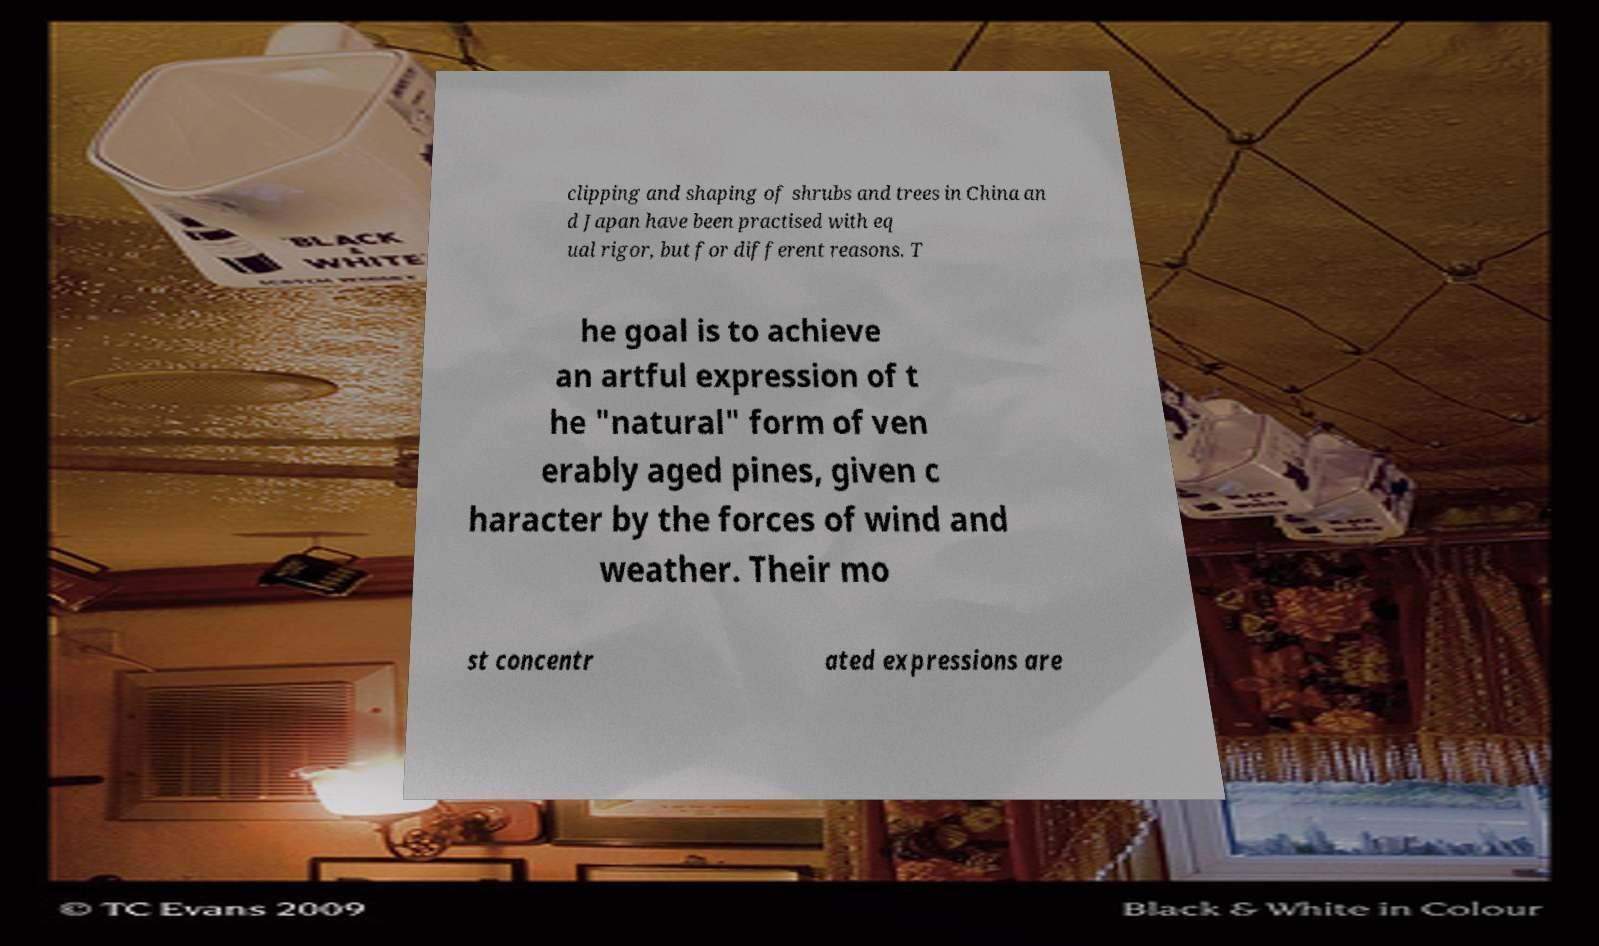Could you extract and type out the text from this image? clipping and shaping of shrubs and trees in China an d Japan have been practised with eq ual rigor, but for different reasons. T he goal is to achieve an artful expression of t he "natural" form of ven erably aged pines, given c haracter by the forces of wind and weather. Their mo st concentr ated expressions are 